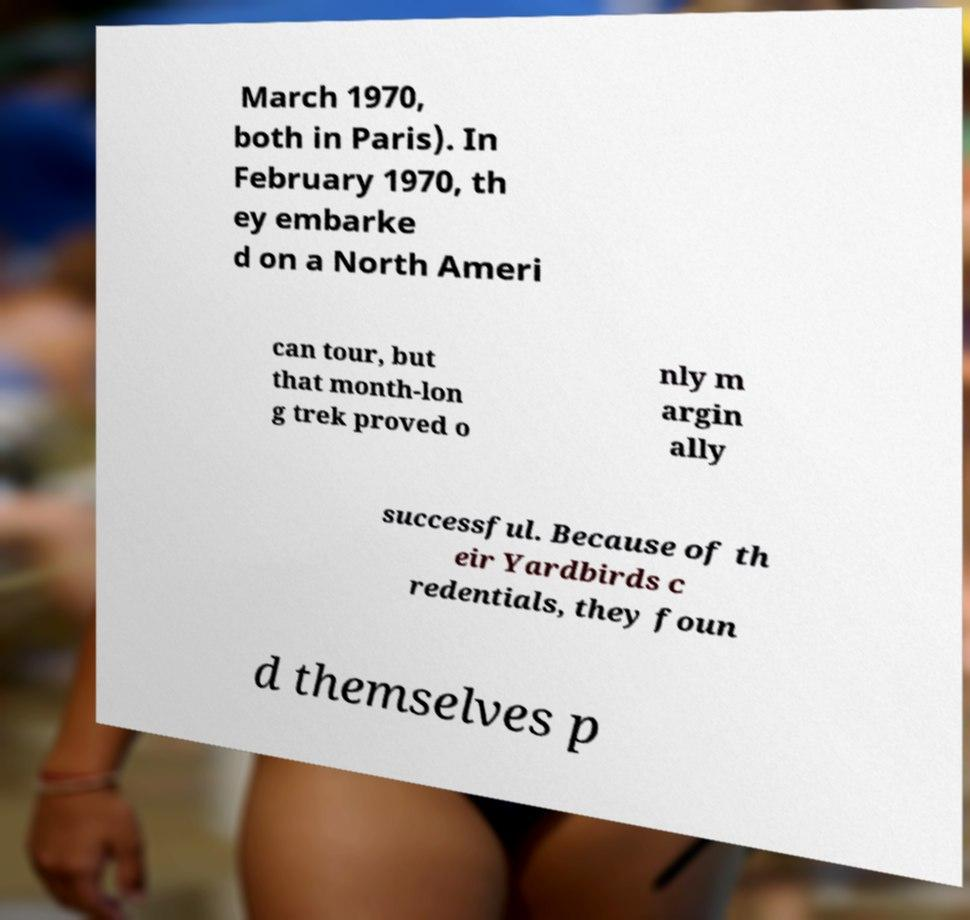Please identify and transcribe the text found in this image. March 1970, both in Paris). In February 1970, th ey embarke d on a North Ameri can tour, but that month-lon g trek proved o nly m argin ally successful. Because of th eir Yardbirds c redentials, they foun d themselves p 